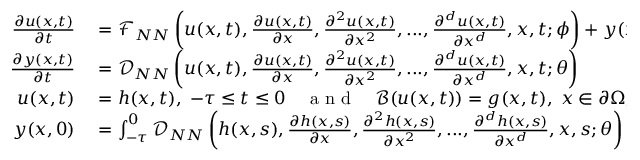Convert formula to latex. <formula><loc_0><loc_0><loc_500><loc_500>\begin{array} { r l } { \frac { \partial u ( x , t ) } { \partial t } } & = \mathcal { F } _ { N N } \left ( u ( x , t ) , \frac { \partial u ( x , t ) } { \partial x } , \frac { \partial ^ { 2 } u ( x , t ) } { \partial x ^ { 2 } } , \dots , \frac { \partial ^ { d } u ( x , t ) } { \partial x ^ { d } } , x , t ; \phi \right ) + y ( x , t ) \, , } \\ { \frac { \partial y ( x , t ) } { \partial t } } & = \mathcal { D } _ { N N } \left ( u ( x , t ) , \frac { \partial u ( x , t ) } { \partial x } , \frac { \partial ^ { 2 } u ( x , t ) } { \partial x ^ { 2 } } , \dots , \frac { \partial ^ { d } u ( x , t ) } { \partial x ^ { d } } , x , t ; \theta \right ) } \\ { u ( x , t ) } & = h ( x , t ) , \, - \tau \leq t \leq 0 \quad a n d \quad \mathcal { B } ( u ( x , t ) ) = g ( x , t ) , \, x \in \partial \Omega , \, t \geq 0 \, , } \\ { y ( x , 0 ) } & = \int _ { - \tau } ^ { 0 } \mathcal { D } _ { N N } \left ( h ( x , s ) , \frac { \partial h ( x , s ) } { \partial x } , \frac { \partial ^ { 2 } h ( x , s ) } { \partial x ^ { 2 } } , \dots , \frac { \partial ^ { d } h ( x , s ) } { \partial x ^ { d } } , x , s ; \theta \right ) d s \, . } \end{array}</formula> 